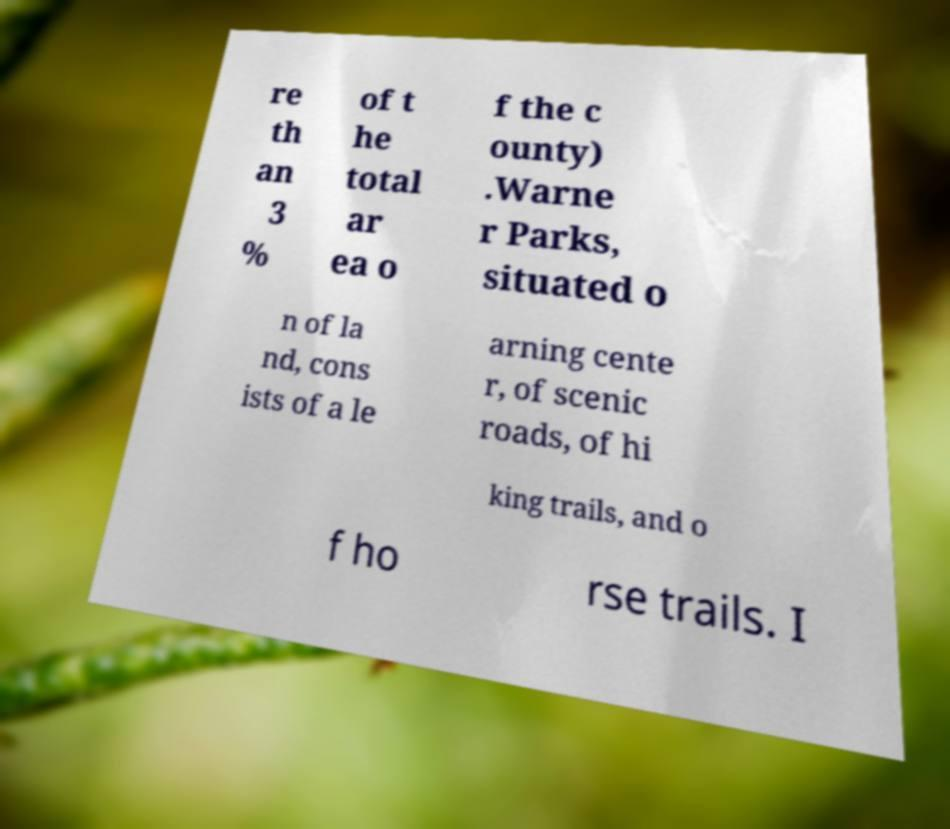Could you assist in decoding the text presented in this image and type it out clearly? re th an 3 % of t he total ar ea o f the c ounty) .Warne r Parks, situated o n of la nd, cons ists of a le arning cente r, of scenic roads, of hi king trails, and o f ho rse trails. I 